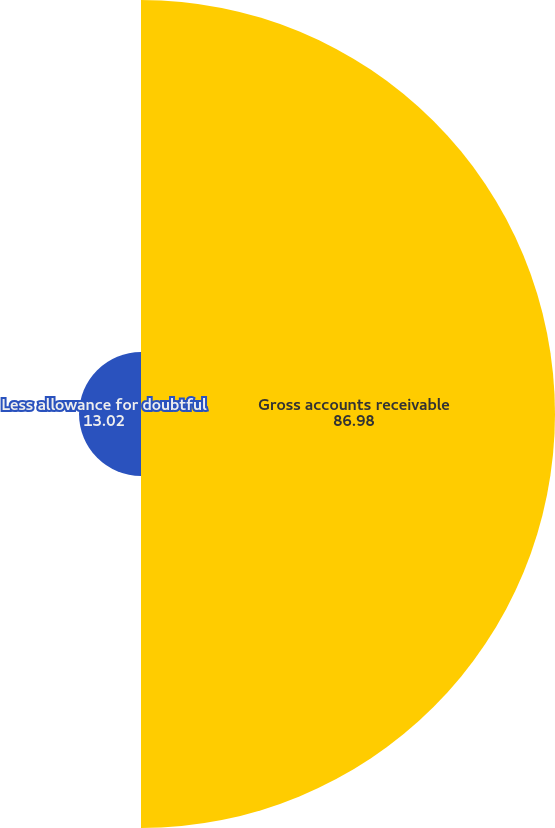<chart> <loc_0><loc_0><loc_500><loc_500><pie_chart><fcel>Gross accounts receivable<fcel>Less allowance for doubtful<nl><fcel>86.98%<fcel>13.02%<nl></chart> 